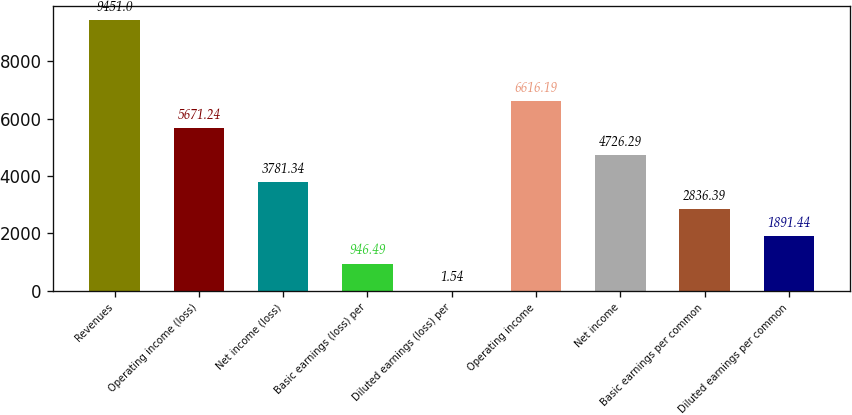Convert chart to OTSL. <chart><loc_0><loc_0><loc_500><loc_500><bar_chart><fcel>Revenues<fcel>Operating income (loss)<fcel>Net income (loss)<fcel>Basic earnings (loss) per<fcel>Diluted earnings (loss) per<fcel>Operating income<fcel>Net income<fcel>Basic earnings per common<fcel>Diluted earnings per common<nl><fcel>9451<fcel>5671.24<fcel>3781.34<fcel>946.49<fcel>1.54<fcel>6616.19<fcel>4726.29<fcel>2836.39<fcel>1891.44<nl></chart> 